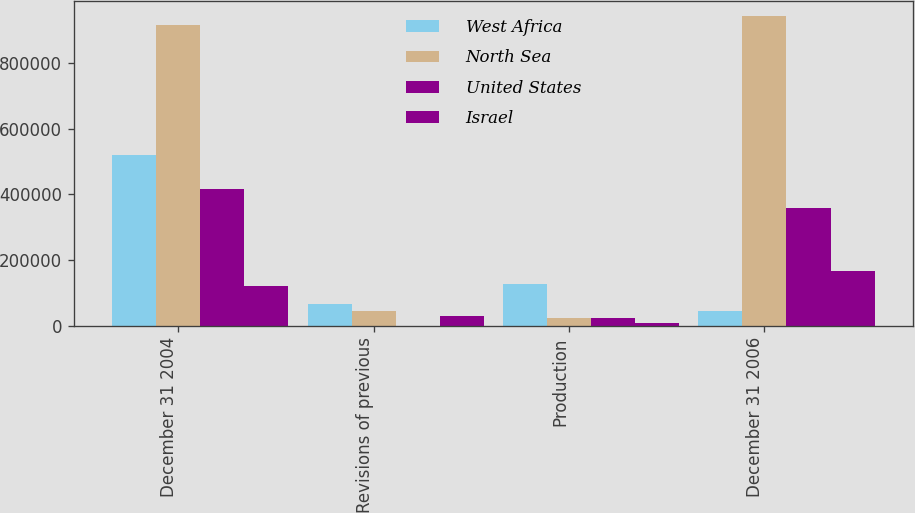Convert chart to OTSL. <chart><loc_0><loc_0><loc_500><loc_500><stacked_bar_chart><ecel><fcel>December 31 2004<fcel>Revisions of previous<fcel>Production<fcel>December 31 2006<nl><fcel>West Africa<fcel>519735<fcel>67003<fcel>125543<fcel>44256<nl><fcel>North Sea<fcel>917409<fcel>44256<fcel>23938<fcel>944699<nl><fcel>United States<fcel>417293<fcel>52<fcel>24228<fcel>359900<nl><fcel>Israel<fcel>119341<fcel>29872<fcel>8321<fcel>167814<nl></chart> 